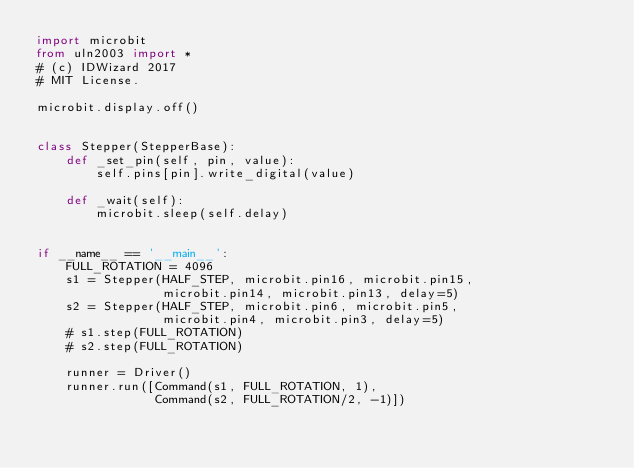<code> <loc_0><loc_0><loc_500><loc_500><_Python_>import microbit
from uln2003 import *
# (c) IDWizard 2017
# MIT License.

microbit.display.off()


class Stepper(StepperBase):
    def _set_pin(self, pin, value):
        self.pins[pin].write_digital(value)

    def _wait(self):
        microbit.sleep(self.delay)


if __name__ == '__main__':
    FULL_ROTATION = 4096
    s1 = Stepper(HALF_STEP, microbit.pin16, microbit.pin15,
                 microbit.pin14, microbit.pin13, delay=5)
    s2 = Stepper(HALF_STEP, microbit.pin6, microbit.pin5,
                 microbit.pin4, microbit.pin3, delay=5)
    # s1.step(FULL_ROTATION)
    # s2.step(FULL_ROTATION)

    runner = Driver()
    runner.run([Command(s1, FULL_ROTATION, 1),
                Command(s2, FULL_ROTATION/2, -1)])
</code> 